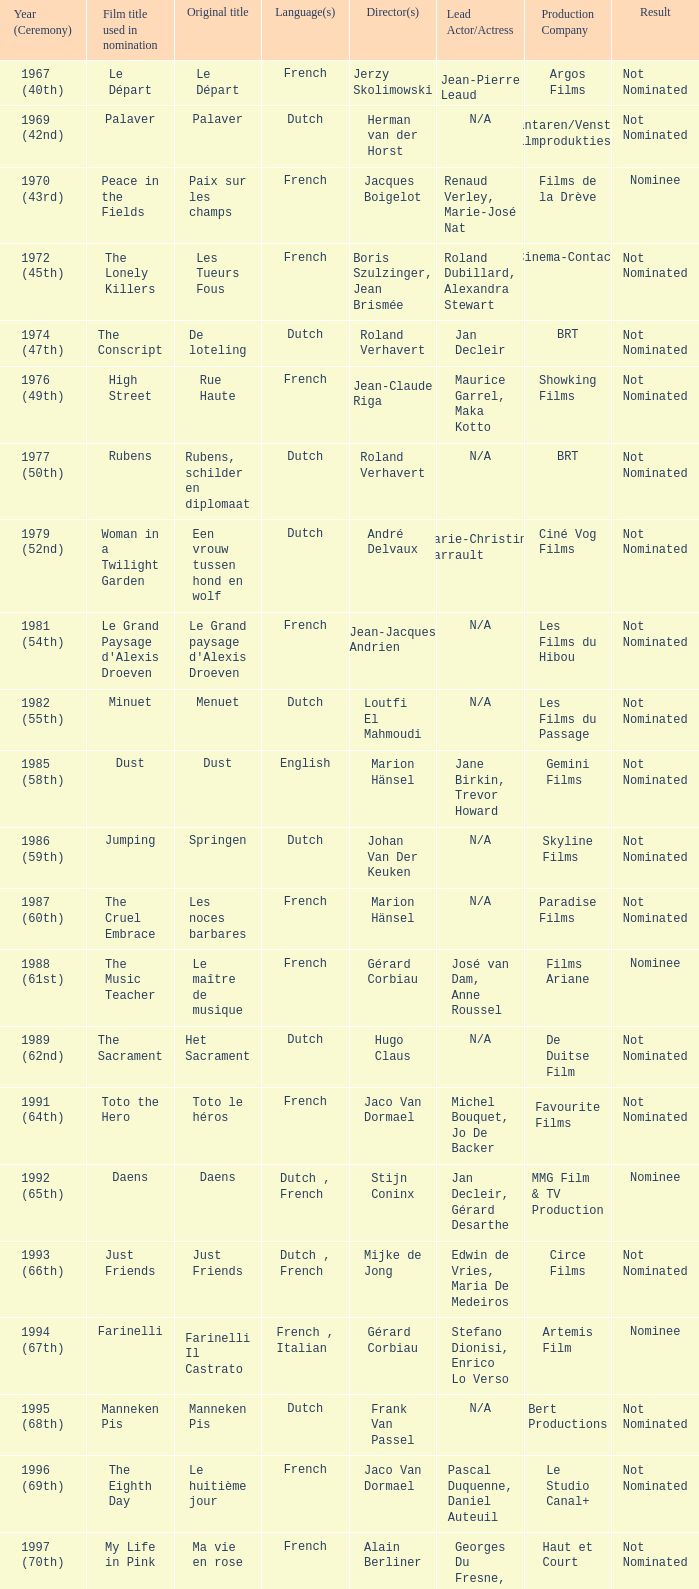What is the language of the film Rosie? Dutch. 